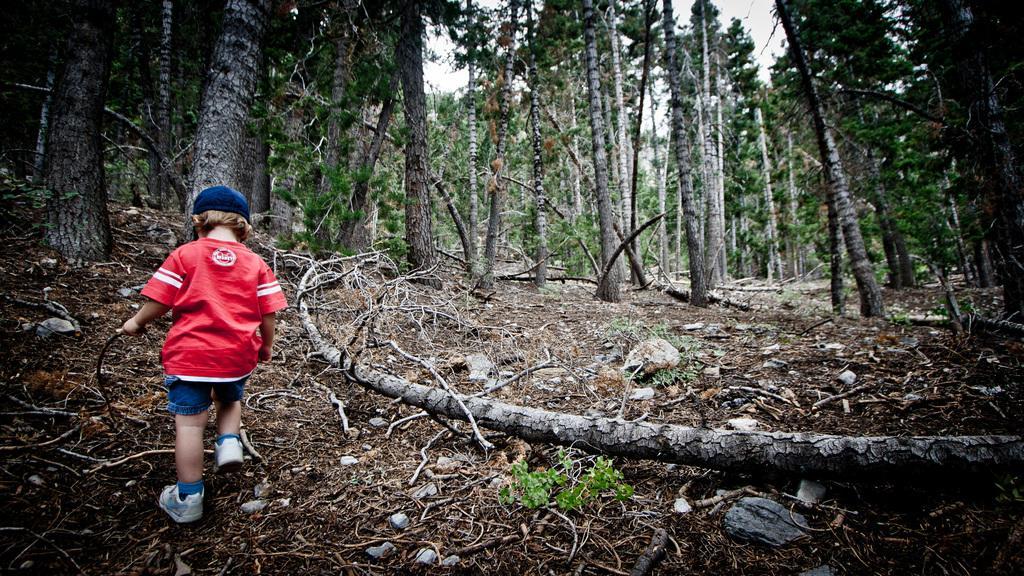What is the main subject of the image? The main subject of the image is a child. What is the child doing in the image? The child is walking on the ground in the image. What object is the child holding? The child is holding a stick in the image. What can be seen in the background of the image? There are trees and the sky visible in the background of the image. What is the child's annual income in the image? The image does not provide information about the child's income, as it is not relevant to the visual content. 